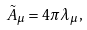<formula> <loc_0><loc_0><loc_500><loc_500>\tilde { A } _ { \mu } = 4 \pi \lambda _ { \mu } ,</formula> 